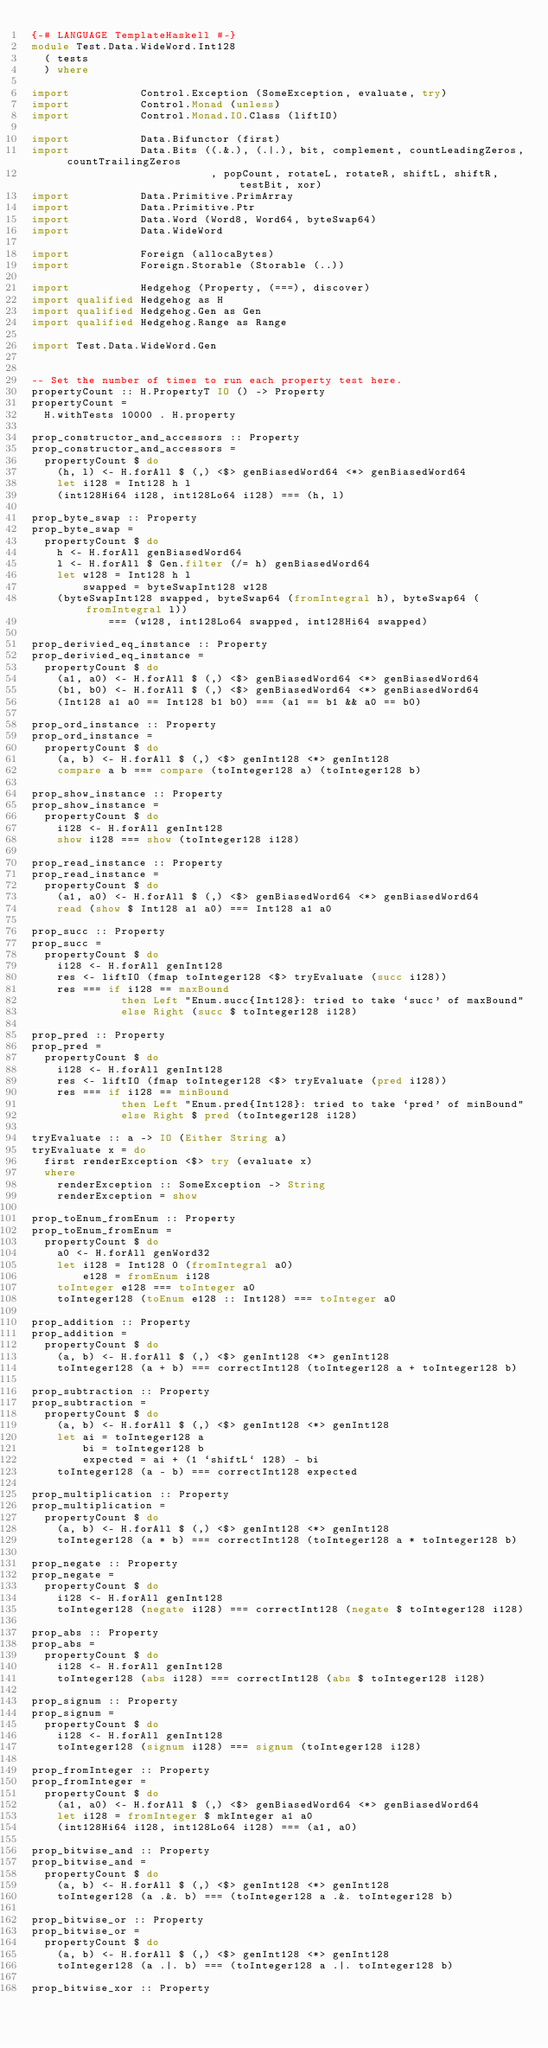<code> <loc_0><loc_0><loc_500><loc_500><_Haskell_>{-# LANGUAGE TemplateHaskell #-}
module Test.Data.WideWord.Int128
  ( tests
  ) where

import           Control.Exception (SomeException, evaluate, try)
import           Control.Monad (unless)
import           Control.Monad.IO.Class (liftIO)

import           Data.Bifunctor (first)
import           Data.Bits ((.&.), (.|.), bit, complement, countLeadingZeros, countTrailingZeros
                            , popCount, rotateL, rotateR, shiftL, shiftR, testBit, xor)
import           Data.Primitive.PrimArray
import           Data.Primitive.Ptr
import           Data.Word (Word8, Word64, byteSwap64)
import           Data.WideWord

import           Foreign (allocaBytes)
import           Foreign.Storable (Storable (..))

import           Hedgehog (Property, (===), discover)
import qualified Hedgehog as H
import qualified Hedgehog.Gen as Gen
import qualified Hedgehog.Range as Range

import Test.Data.WideWord.Gen


-- Set the number of times to run each property test here.
propertyCount :: H.PropertyT IO () -> Property
propertyCount =
  H.withTests 10000 . H.property

prop_constructor_and_accessors :: Property
prop_constructor_and_accessors =
  propertyCount $ do
    (h, l) <- H.forAll $ (,) <$> genBiasedWord64 <*> genBiasedWord64
    let i128 = Int128 h l
    (int128Hi64 i128, int128Lo64 i128) === (h, l)

prop_byte_swap :: Property
prop_byte_swap =
  propertyCount $ do
    h <- H.forAll genBiasedWord64
    l <- H.forAll $ Gen.filter (/= h) genBiasedWord64
    let w128 = Int128 h l
        swapped = byteSwapInt128 w128
    (byteSwapInt128 swapped, byteSwap64 (fromIntegral h), byteSwap64 (fromIntegral l))
            === (w128, int128Lo64 swapped, int128Hi64 swapped)

prop_derivied_eq_instance :: Property
prop_derivied_eq_instance =
  propertyCount $ do
    (a1, a0) <- H.forAll $ (,) <$> genBiasedWord64 <*> genBiasedWord64
    (b1, b0) <- H.forAll $ (,) <$> genBiasedWord64 <*> genBiasedWord64
    (Int128 a1 a0 == Int128 b1 b0) === (a1 == b1 && a0 == b0)

prop_ord_instance :: Property
prop_ord_instance =
  propertyCount $ do
    (a, b) <- H.forAll $ (,) <$> genInt128 <*> genInt128
    compare a b === compare (toInteger128 a) (toInteger128 b)

prop_show_instance :: Property
prop_show_instance =
  propertyCount $ do
    i128 <- H.forAll genInt128
    show i128 === show (toInteger128 i128)

prop_read_instance :: Property
prop_read_instance =
  propertyCount $ do
    (a1, a0) <- H.forAll $ (,) <$> genBiasedWord64 <*> genBiasedWord64
    read (show $ Int128 a1 a0) === Int128 a1 a0

prop_succ :: Property
prop_succ =
  propertyCount $ do
    i128 <- H.forAll genInt128
    res <- liftIO (fmap toInteger128 <$> tryEvaluate (succ i128))
    res === if i128 == maxBound
              then Left "Enum.succ{Int128}: tried to take `succ' of maxBound"
              else Right (succ $ toInteger128 i128)

prop_pred :: Property
prop_pred =
  propertyCount $ do
    i128 <- H.forAll genInt128
    res <- liftIO (fmap toInteger128 <$> tryEvaluate (pred i128))
    res === if i128 == minBound
              then Left "Enum.pred{Int128}: tried to take `pred' of minBound"
              else Right $ pred (toInteger128 i128)

tryEvaluate :: a -> IO (Either String a)
tryEvaluate x = do
  first renderException <$> try (evaluate x)
  where
    renderException :: SomeException -> String
    renderException = show

prop_toEnum_fromEnum :: Property
prop_toEnum_fromEnum =
  propertyCount $ do
    a0 <- H.forAll genWord32
    let i128 = Int128 0 (fromIntegral a0)
        e128 = fromEnum i128
    toInteger e128 === toInteger a0
    toInteger128 (toEnum e128 :: Int128) === toInteger a0

prop_addition :: Property
prop_addition =
  propertyCount $ do
    (a, b) <- H.forAll $ (,) <$> genInt128 <*> genInt128
    toInteger128 (a + b) === correctInt128 (toInteger128 a + toInteger128 b)

prop_subtraction :: Property
prop_subtraction =
  propertyCount $ do
    (a, b) <- H.forAll $ (,) <$> genInt128 <*> genInt128
    let ai = toInteger128 a
        bi = toInteger128 b
        expected = ai + (1 `shiftL` 128) - bi
    toInteger128 (a - b) === correctInt128 expected

prop_multiplication :: Property
prop_multiplication =
  propertyCount $ do
    (a, b) <- H.forAll $ (,) <$> genInt128 <*> genInt128
    toInteger128 (a * b) === correctInt128 (toInteger128 a * toInteger128 b)

prop_negate :: Property
prop_negate =
  propertyCount $ do
    i128 <- H.forAll genInt128
    toInteger128 (negate i128) === correctInt128 (negate $ toInteger128 i128)

prop_abs :: Property
prop_abs =
  propertyCount $ do
    i128 <- H.forAll genInt128
    toInteger128 (abs i128) === correctInt128 (abs $ toInteger128 i128)

prop_signum :: Property
prop_signum =
  propertyCount $ do
    i128 <- H.forAll genInt128
    toInteger128 (signum i128) === signum (toInteger128 i128)

prop_fromInteger :: Property
prop_fromInteger =
  propertyCount $ do
    (a1, a0) <- H.forAll $ (,) <$> genBiasedWord64 <*> genBiasedWord64
    let i128 = fromInteger $ mkInteger a1 a0
    (int128Hi64 i128, int128Lo64 i128) === (a1, a0)

prop_bitwise_and :: Property
prop_bitwise_and =
  propertyCount $ do
    (a, b) <- H.forAll $ (,) <$> genInt128 <*> genInt128
    toInteger128 (a .&. b) === (toInteger128 a .&. toInteger128 b)

prop_bitwise_or :: Property
prop_bitwise_or =
  propertyCount $ do
    (a, b) <- H.forAll $ (,) <$> genInt128 <*> genInt128
    toInteger128 (a .|. b) === (toInteger128 a .|. toInteger128 b)

prop_bitwise_xor :: Property</code> 